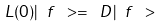Convert formula to latex. <formula><loc_0><loc_0><loc_500><loc_500>L ( 0 ) | \ f \ > = \ D | \ f \ ></formula> 